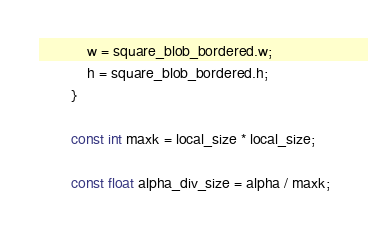<code> <loc_0><loc_0><loc_500><loc_500><_C++_>
            w = square_blob_bordered.w;
            h = square_blob_bordered.h;
        }

        const int maxk = local_size * local_size;

        const float alpha_div_size = alpha / maxk;
</code> 